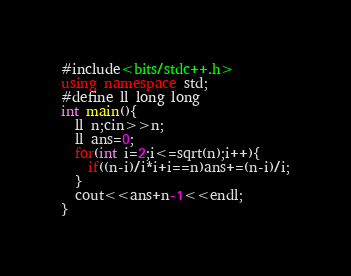<code> <loc_0><loc_0><loc_500><loc_500><_C++_>#include<bits/stdc++.h>
using namespace std;
#define ll long long
int main(){
  ll n;cin>>n;
  ll ans=0;
  for(int i=2;i<=sqrt(n);i++){
    if((n-i)/i*i+i==n)ans+=(n-i)/i;
  }
  cout<<ans+n-1<<endl;
}
</code> 